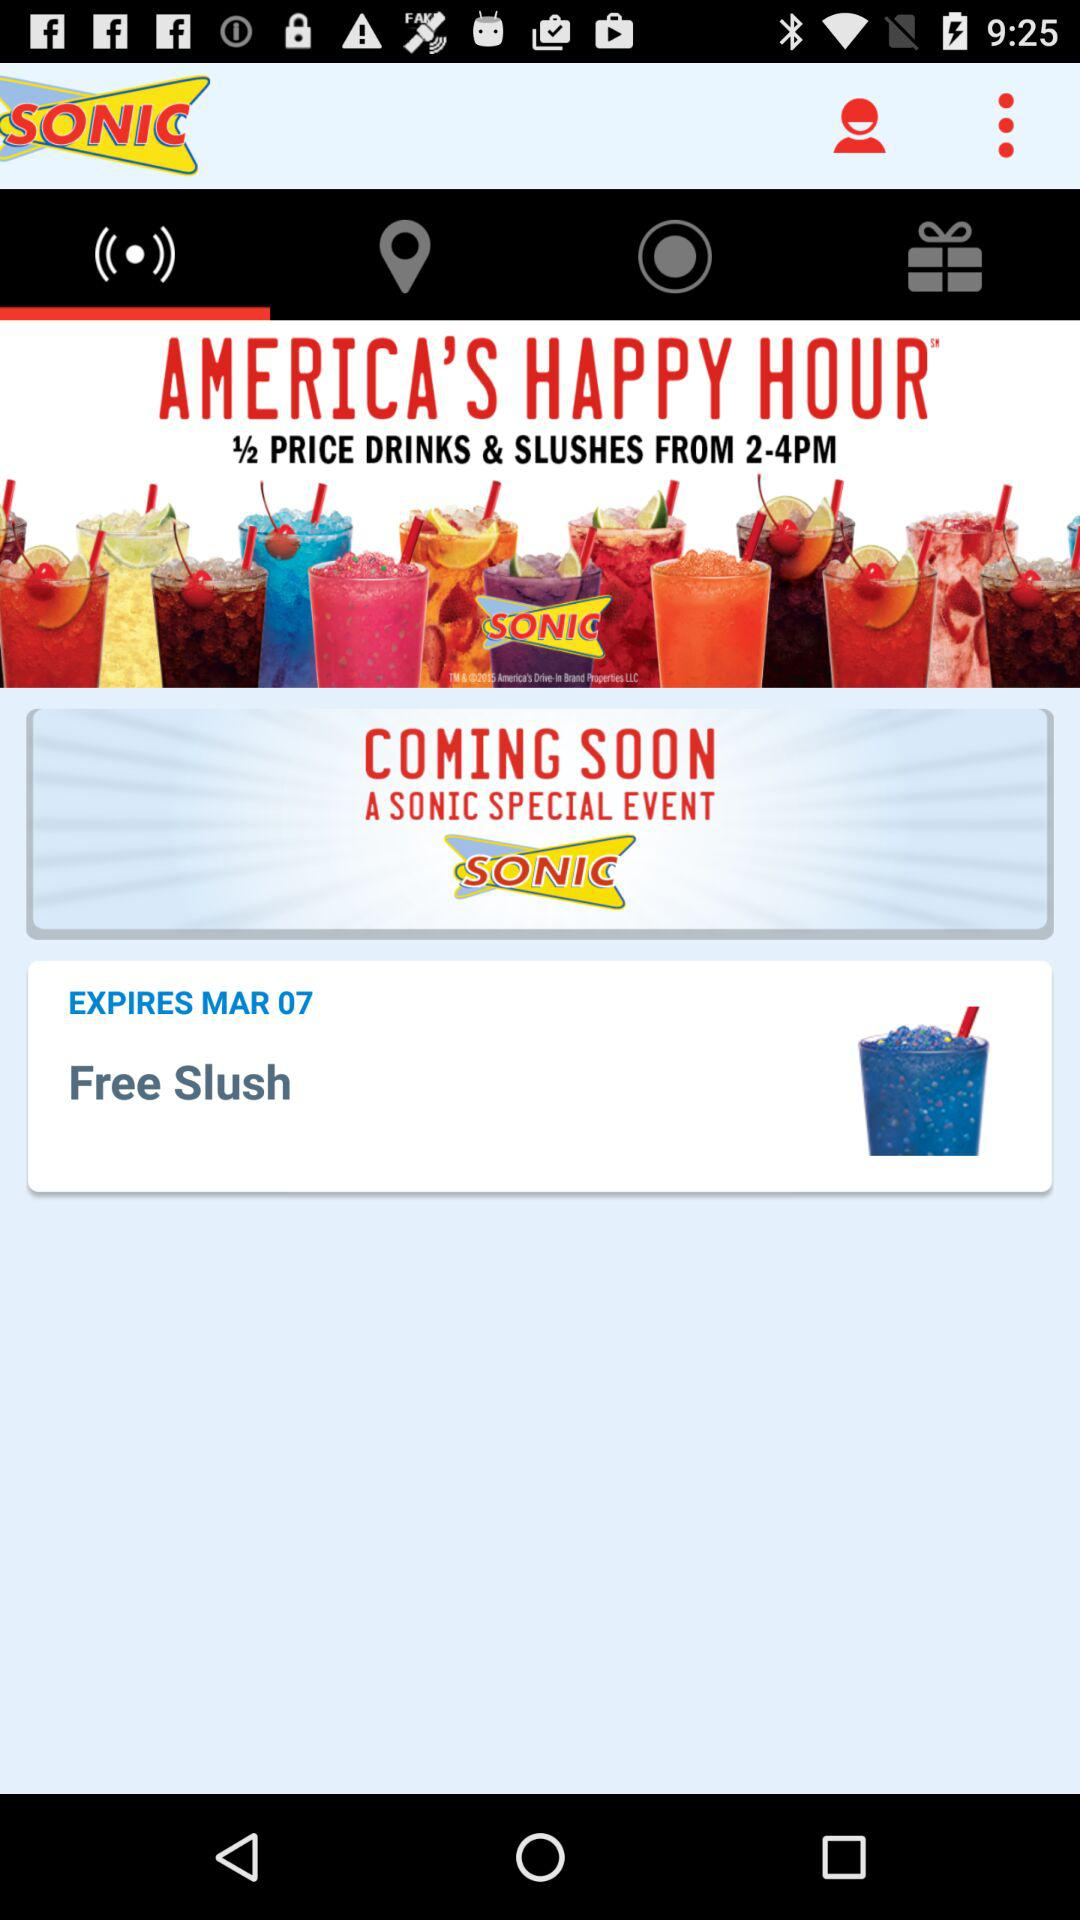What are the offers in "AMERICA'S HAPPY HOUR"? The offer is "1/2 PRICE DRINKS & SLUSHES FROM 2-4PM". 